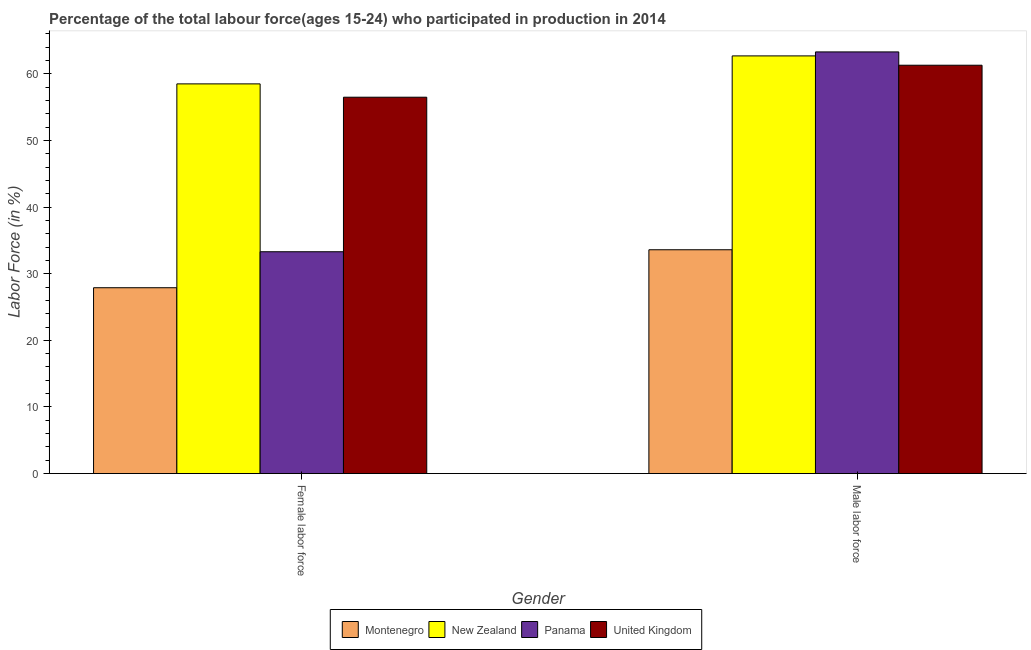How many different coloured bars are there?
Offer a very short reply. 4. How many groups of bars are there?
Offer a very short reply. 2. Are the number of bars per tick equal to the number of legend labels?
Offer a very short reply. Yes. Are the number of bars on each tick of the X-axis equal?
Make the answer very short. Yes. How many bars are there on the 2nd tick from the right?
Offer a very short reply. 4. What is the label of the 2nd group of bars from the left?
Keep it short and to the point. Male labor force. What is the percentage of female labor force in United Kingdom?
Your response must be concise. 56.5. Across all countries, what is the maximum percentage of female labor force?
Make the answer very short. 58.5. Across all countries, what is the minimum percentage of male labour force?
Keep it short and to the point. 33.6. In which country was the percentage of female labor force maximum?
Keep it short and to the point. New Zealand. In which country was the percentage of female labor force minimum?
Offer a very short reply. Montenegro. What is the total percentage of male labour force in the graph?
Ensure brevity in your answer.  220.9. What is the difference between the percentage of male labour force in New Zealand and that in United Kingdom?
Ensure brevity in your answer.  1.4. What is the difference between the percentage of male labour force in Montenegro and the percentage of female labor force in United Kingdom?
Provide a short and direct response. -22.9. What is the average percentage of male labour force per country?
Your answer should be compact. 55.22. What is the difference between the percentage of male labour force and percentage of female labor force in New Zealand?
Your answer should be compact. 4.2. What is the ratio of the percentage of male labour force in Montenegro to that in Panama?
Ensure brevity in your answer.  0.53. In how many countries, is the percentage of female labor force greater than the average percentage of female labor force taken over all countries?
Give a very brief answer. 2. What does the 1st bar from the left in Female labor force represents?
Make the answer very short. Montenegro. What does the 1st bar from the right in Male labor force represents?
Ensure brevity in your answer.  United Kingdom. Does the graph contain any zero values?
Give a very brief answer. No. Where does the legend appear in the graph?
Your response must be concise. Bottom center. How many legend labels are there?
Give a very brief answer. 4. What is the title of the graph?
Your answer should be compact. Percentage of the total labour force(ages 15-24) who participated in production in 2014. Does "Cayman Islands" appear as one of the legend labels in the graph?
Your answer should be compact. No. What is the label or title of the X-axis?
Offer a terse response. Gender. What is the Labor Force (in %) of Montenegro in Female labor force?
Ensure brevity in your answer.  27.9. What is the Labor Force (in %) in New Zealand in Female labor force?
Your answer should be very brief. 58.5. What is the Labor Force (in %) in Panama in Female labor force?
Your answer should be compact. 33.3. What is the Labor Force (in %) in United Kingdom in Female labor force?
Offer a very short reply. 56.5. What is the Labor Force (in %) in Montenegro in Male labor force?
Provide a short and direct response. 33.6. What is the Labor Force (in %) of New Zealand in Male labor force?
Provide a short and direct response. 62.7. What is the Labor Force (in %) of Panama in Male labor force?
Ensure brevity in your answer.  63.3. What is the Labor Force (in %) of United Kingdom in Male labor force?
Your response must be concise. 61.3. Across all Gender, what is the maximum Labor Force (in %) in Montenegro?
Offer a very short reply. 33.6. Across all Gender, what is the maximum Labor Force (in %) in New Zealand?
Your response must be concise. 62.7. Across all Gender, what is the maximum Labor Force (in %) of Panama?
Your response must be concise. 63.3. Across all Gender, what is the maximum Labor Force (in %) of United Kingdom?
Give a very brief answer. 61.3. Across all Gender, what is the minimum Labor Force (in %) in Montenegro?
Provide a succinct answer. 27.9. Across all Gender, what is the minimum Labor Force (in %) in New Zealand?
Provide a short and direct response. 58.5. Across all Gender, what is the minimum Labor Force (in %) in Panama?
Provide a short and direct response. 33.3. Across all Gender, what is the minimum Labor Force (in %) of United Kingdom?
Keep it short and to the point. 56.5. What is the total Labor Force (in %) of Montenegro in the graph?
Provide a short and direct response. 61.5. What is the total Labor Force (in %) of New Zealand in the graph?
Keep it short and to the point. 121.2. What is the total Labor Force (in %) in Panama in the graph?
Offer a very short reply. 96.6. What is the total Labor Force (in %) of United Kingdom in the graph?
Provide a succinct answer. 117.8. What is the difference between the Labor Force (in %) in New Zealand in Female labor force and that in Male labor force?
Keep it short and to the point. -4.2. What is the difference between the Labor Force (in %) of Montenegro in Female labor force and the Labor Force (in %) of New Zealand in Male labor force?
Your answer should be compact. -34.8. What is the difference between the Labor Force (in %) in Montenegro in Female labor force and the Labor Force (in %) in Panama in Male labor force?
Provide a short and direct response. -35.4. What is the difference between the Labor Force (in %) of Montenegro in Female labor force and the Labor Force (in %) of United Kingdom in Male labor force?
Give a very brief answer. -33.4. What is the difference between the Labor Force (in %) of New Zealand in Female labor force and the Labor Force (in %) of United Kingdom in Male labor force?
Make the answer very short. -2.8. What is the average Labor Force (in %) of Montenegro per Gender?
Keep it short and to the point. 30.75. What is the average Labor Force (in %) of New Zealand per Gender?
Your answer should be very brief. 60.6. What is the average Labor Force (in %) of Panama per Gender?
Offer a terse response. 48.3. What is the average Labor Force (in %) of United Kingdom per Gender?
Provide a short and direct response. 58.9. What is the difference between the Labor Force (in %) in Montenegro and Labor Force (in %) in New Zealand in Female labor force?
Provide a succinct answer. -30.6. What is the difference between the Labor Force (in %) in Montenegro and Labor Force (in %) in Panama in Female labor force?
Your response must be concise. -5.4. What is the difference between the Labor Force (in %) of Montenegro and Labor Force (in %) of United Kingdom in Female labor force?
Provide a short and direct response. -28.6. What is the difference between the Labor Force (in %) in New Zealand and Labor Force (in %) in Panama in Female labor force?
Your response must be concise. 25.2. What is the difference between the Labor Force (in %) of Panama and Labor Force (in %) of United Kingdom in Female labor force?
Ensure brevity in your answer.  -23.2. What is the difference between the Labor Force (in %) of Montenegro and Labor Force (in %) of New Zealand in Male labor force?
Your response must be concise. -29.1. What is the difference between the Labor Force (in %) in Montenegro and Labor Force (in %) in Panama in Male labor force?
Ensure brevity in your answer.  -29.7. What is the difference between the Labor Force (in %) of Montenegro and Labor Force (in %) of United Kingdom in Male labor force?
Keep it short and to the point. -27.7. What is the difference between the Labor Force (in %) in New Zealand and Labor Force (in %) in Panama in Male labor force?
Offer a very short reply. -0.6. What is the difference between the Labor Force (in %) of New Zealand and Labor Force (in %) of United Kingdom in Male labor force?
Keep it short and to the point. 1.4. What is the difference between the Labor Force (in %) of Panama and Labor Force (in %) of United Kingdom in Male labor force?
Ensure brevity in your answer.  2. What is the ratio of the Labor Force (in %) of Montenegro in Female labor force to that in Male labor force?
Offer a very short reply. 0.83. What is the ratio of the Labor Force (in %) of New Zealand in Female labor force to that in Male labor force?
Your response must be concise. 0.93. What is the ratio of the Labor Force (in %) in Panama in Female labor force to that in Male labor force?
Offer a terse response. 0.53. What is the ratio of the Labor Force (in %) in United Kingdom in Female labor force to that in Male labor force?
Your response must be concise. 0.92. What is the difference between the highest and the second highest Labor Force (in %) in Panama?
Your answer should be compact. 30. What is the difference between the highest and the second highest Labor Force (in %) in United Kingdom?
Your answer should be compact. 4.8. What is the difference between the highest and the lowest Labor Force (in %) of Montenegro?
Your response must be concise. 5.7. What is the difference between the highest and the lowest Labor Force (in %) of New Zealand?
Offer a very short reply. 4.2. What is the difference between the highest and the lowest Labor Force (in %) of United Kingdom?
Your response must be concise. 4.8. 